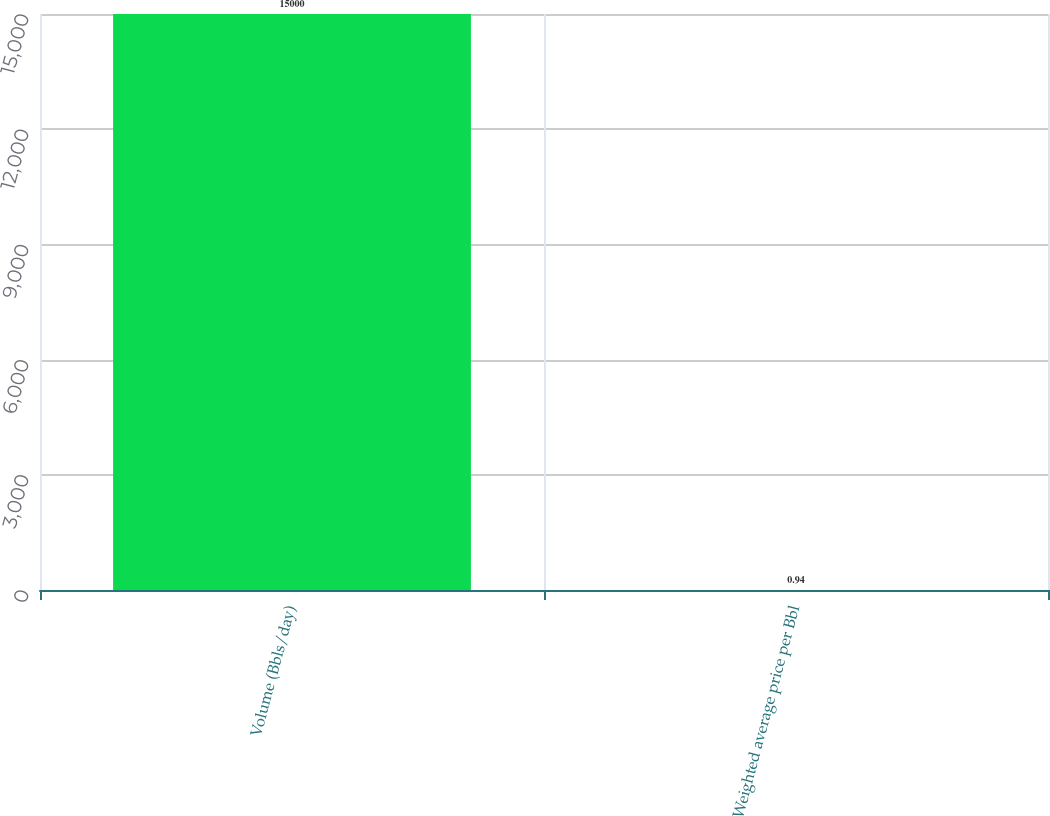Convert chart to OTSL. <chart><loc_0><loc_0><loc_500><loc_500><bar_chart><fcel>Volume (Bbls/day)<fcel>Weighted average price per Bbl<nl><fcel>15000<fcel>0.94<nl></chart> 